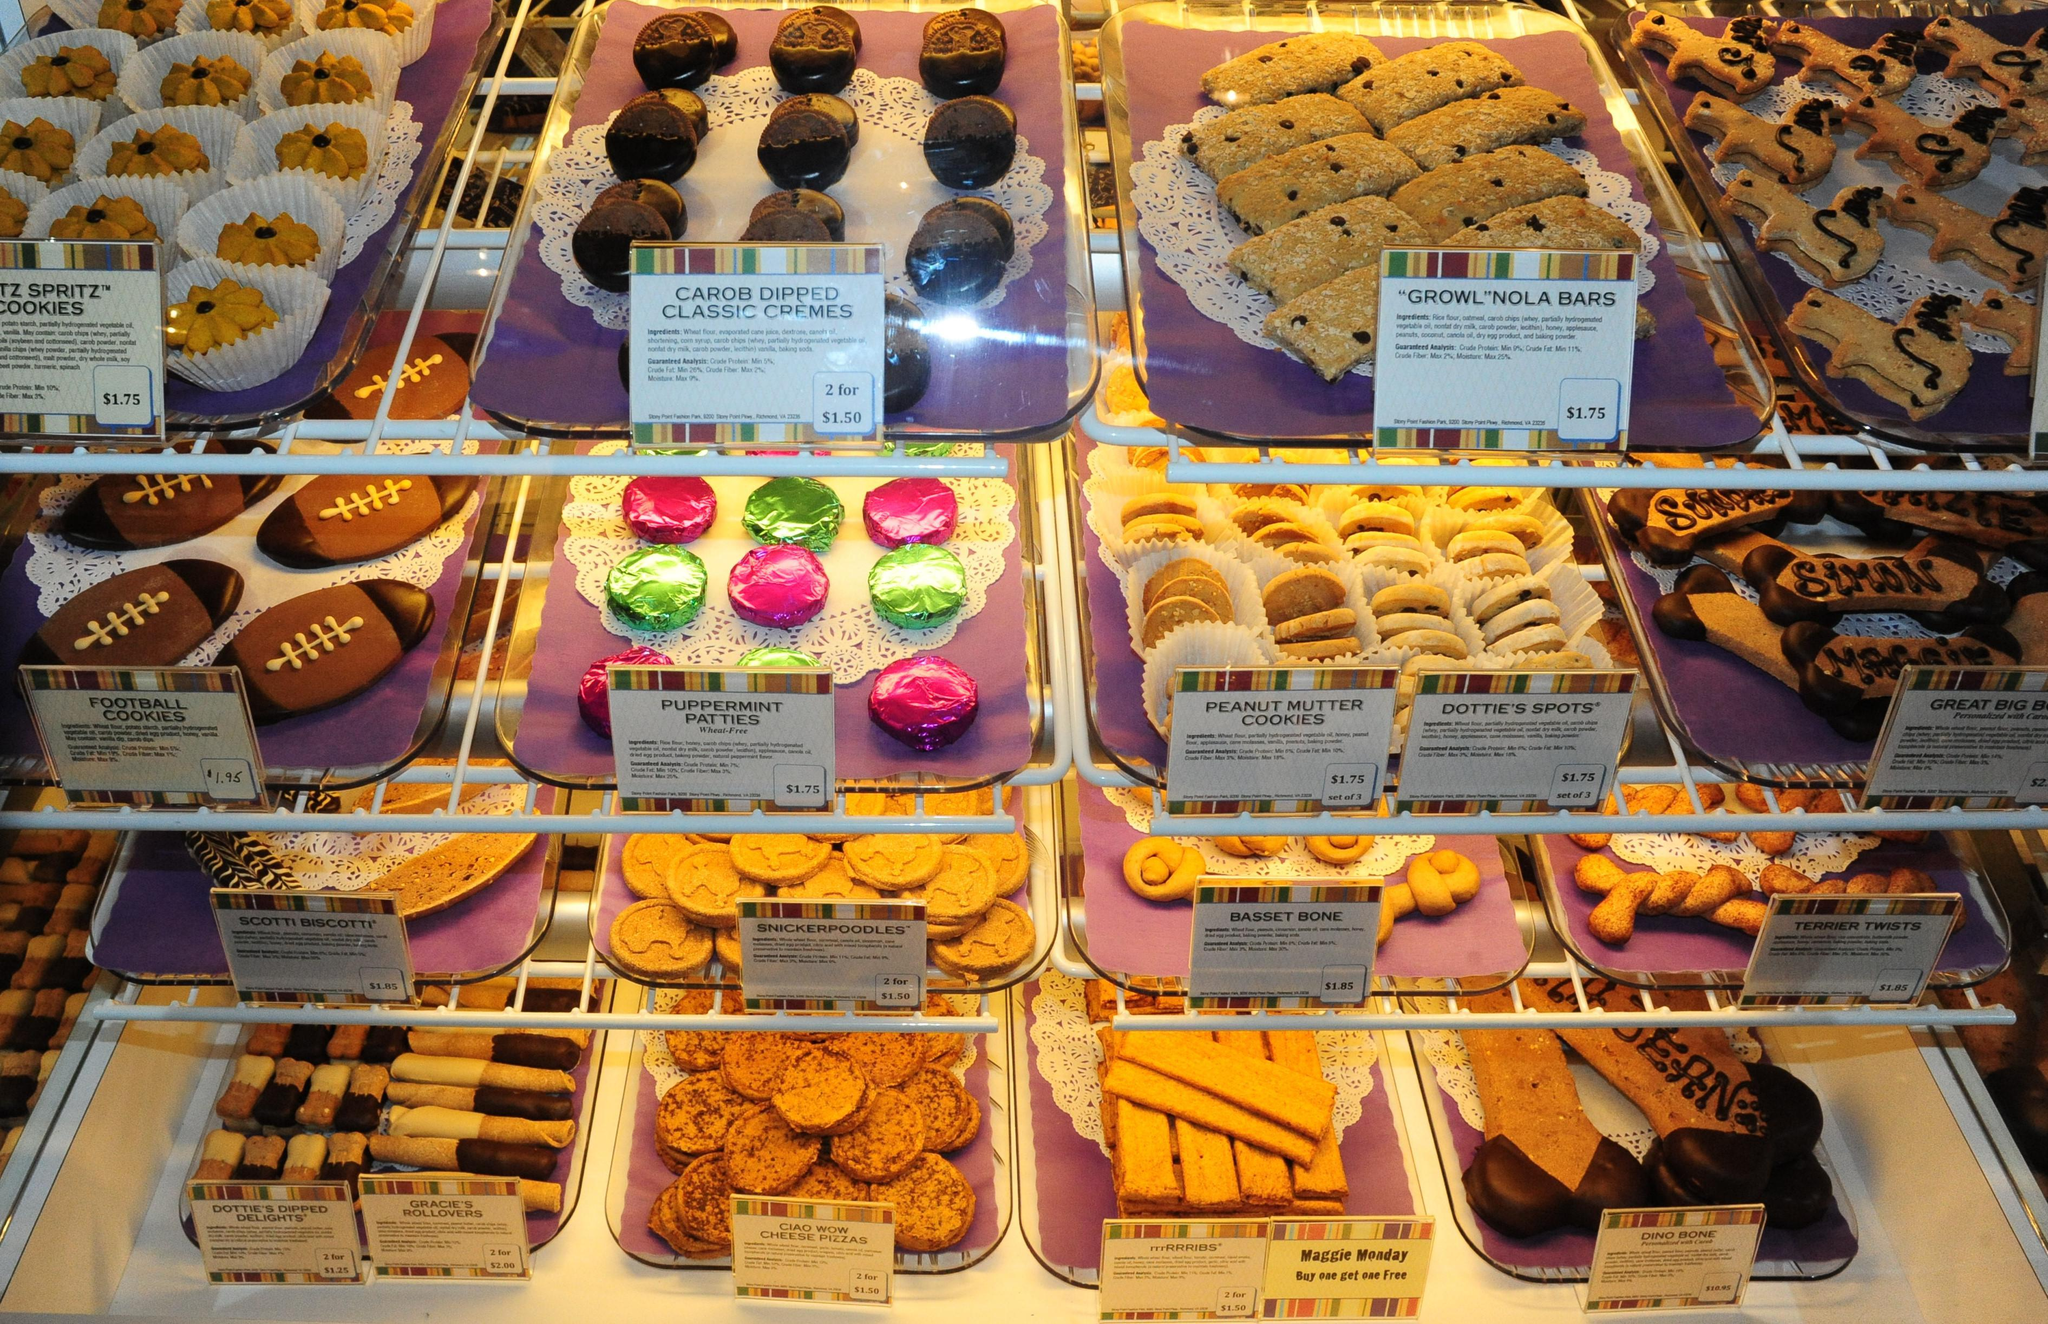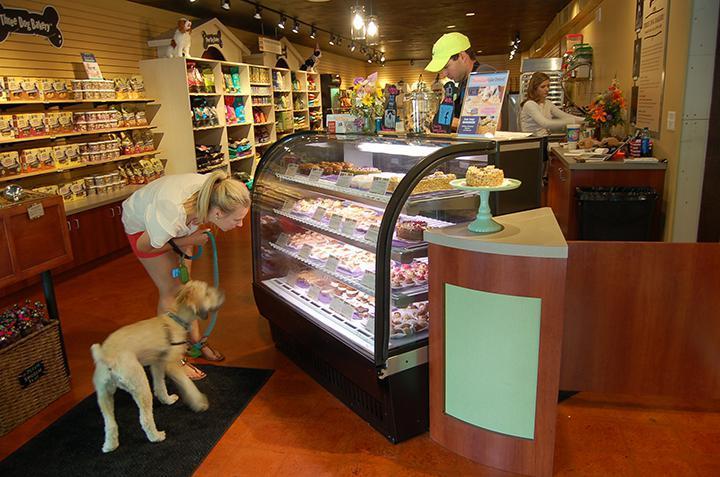The first image is the image on the left, the second image is the image on the right. Assess this claim about the two images: "In one of the images, a dog is looking at the cakes.". Correct or not? Answer yes or no. Yes. The first image is the image on the left, the second image is the image on the right. For the images shown, is this caption "A real dog is standing on all fours in front of a display case in one image." true? Answer yes or no. Yes. 